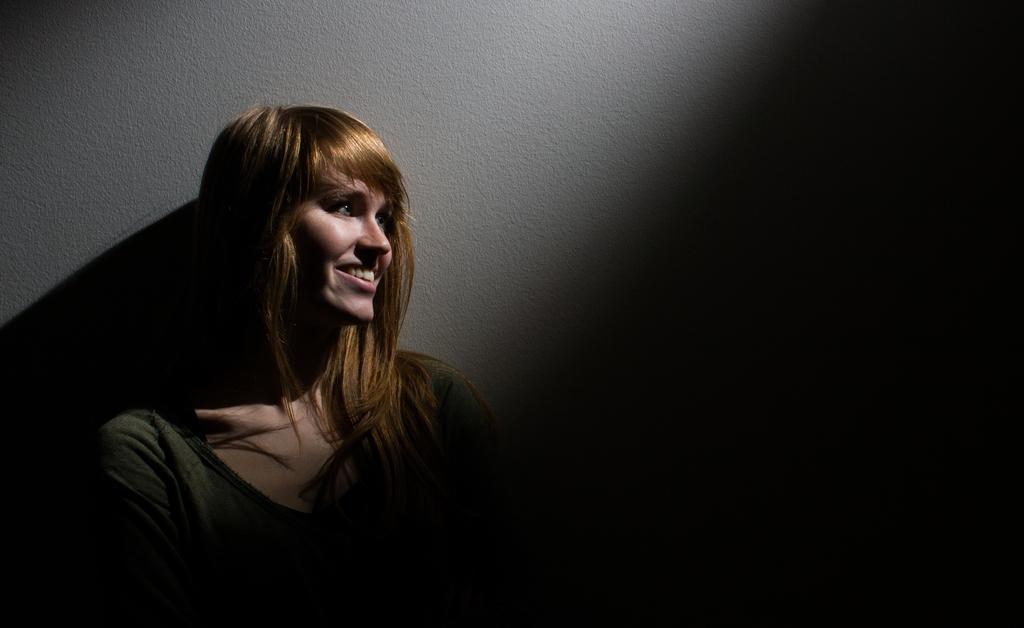Who is the main subject in the foreground of the image? There is a woman in the foreground of the image. What is the woman doing in the image? The woman is standing in front of a wall. What is the woman's facial expression in the image? The woman has a smile on her face. How would you describe the lighting on the right side of the image? The right side of the image appears to be dark. How many dimes can be seen falling from the woman's hand in the image? There are no dimes present in the image, and the woman's hand is not shown making any such action. 